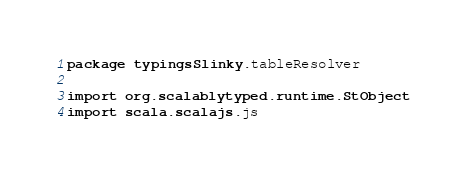Convert code to text. <code><loc_0><loc_0><loc_500><loc_500><_Scala_>package typingsSlinky.tableResolver

import org.scalablytyped.runtime.StObject
import scala.scalajs.js</code> 